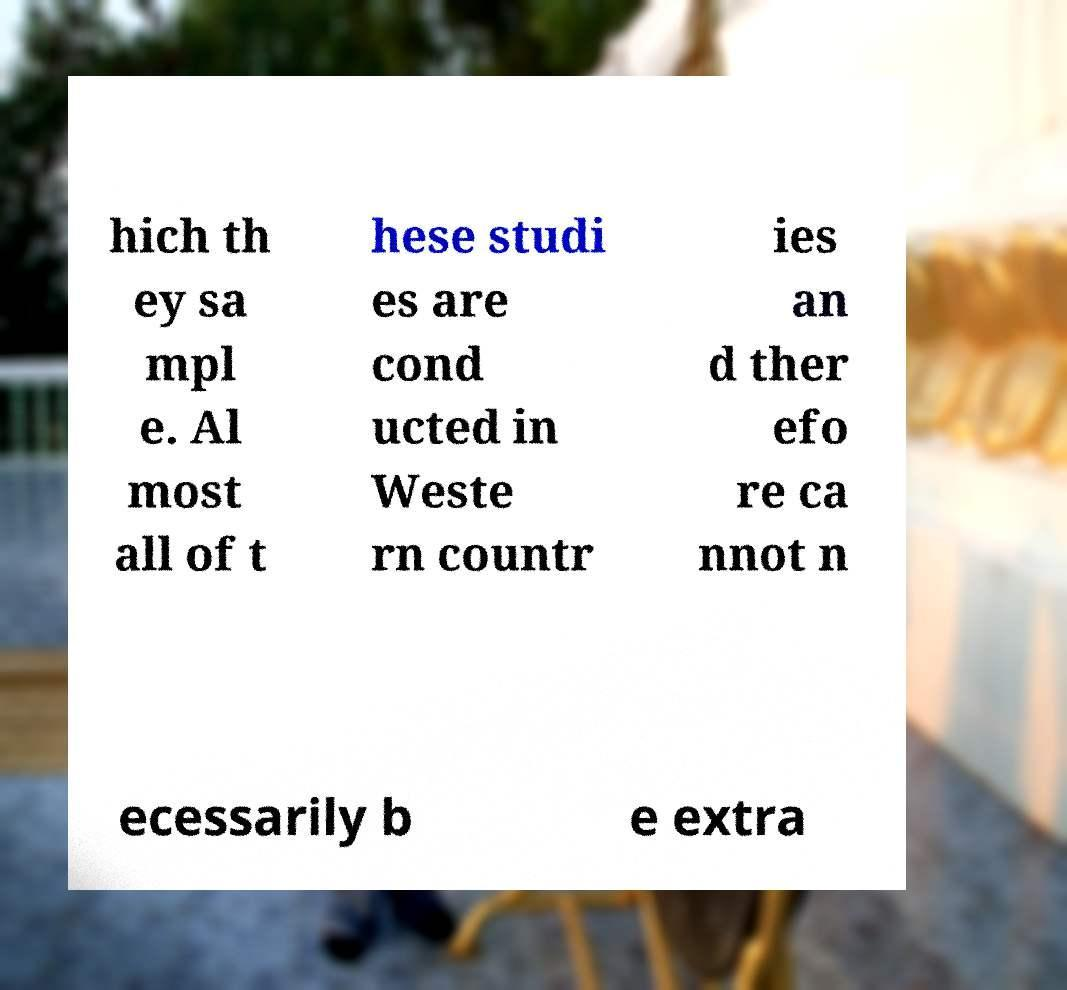Could you extract and type out the text from this image? hich th ey sa mpl e. Al most all of t hese studi es are cond ucted in Weste rn countr ies an d ther efo re ca nnot n ecessarily b e extra 